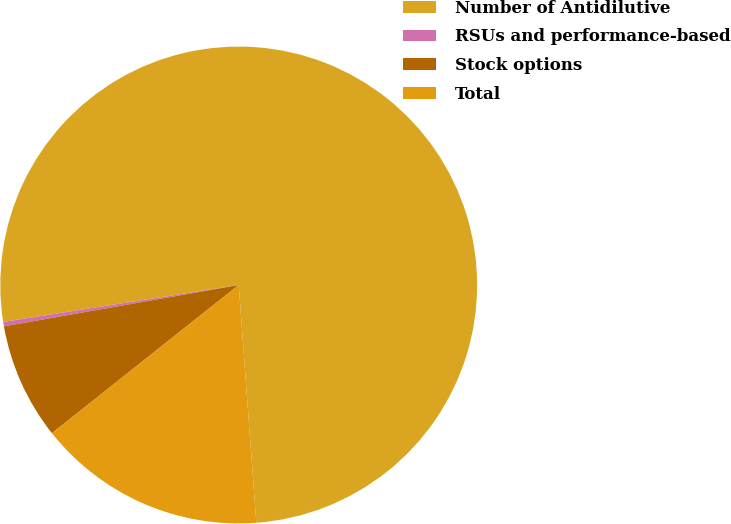<chart> <loc_0><loc_0><loc_500><loc_500><pie_chart><fcel>Number of Antidilutive<fcel>RSUs and performance-based<fcel>Stock options<fcel>Total<nl><fcel>76.29%<fcel>0.3%<fcel>7.9%<fcel>15.5%<nl></chart> 